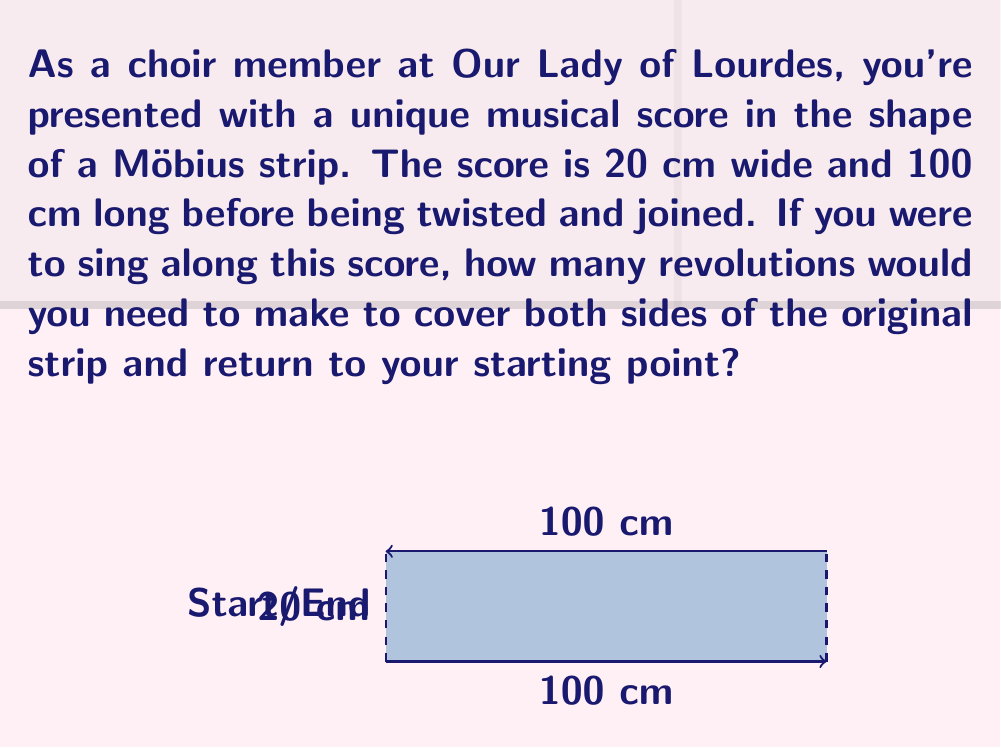Provide a solution to this math problem. Let's approach this step-by-step:

1) A Möbius strip is created by taking a rectangular strip and giving it a half-twist before joining the ends.

2) The key property of a Möbius strip is that it has only one side and one edge. This means that if you start tracing a line down the center of the strip, you will eventually return to your starting point having covered what appears to be both sides of the original strip.

3) To calculate the number of revolutions, we need to consider the length of the path we're tracing:

   - The original strip is 100 cm long.
   - When we trace along the Möbius strip, we cover this entire length once.
   - However, to return to our starting point on a Möbius strip, we need to traverse the length twice.

4) So, the total distance traveled is:

   $$ 2 \times 100 \text{ cm} = 200 \text{ cm} $$

5) Now, we need to consider how this relates to revolutions around the strip:

   - One revolution around the strip covers 100 cm (the original length).
   - We travel 200 cm in total.

6) Therefore, the number of revolutions is:

   $$ \text{Revolutions} = \frac{\text{Total distance}}{\text{Distance per revolution}} = \frac{200 \text{ cm}}{100 \text{ cm}} = 2 $$

Thus, you would need to make 2 revolutions to cover both sides of the original strip and return to your starting point.
Answer: 2 revolutions 